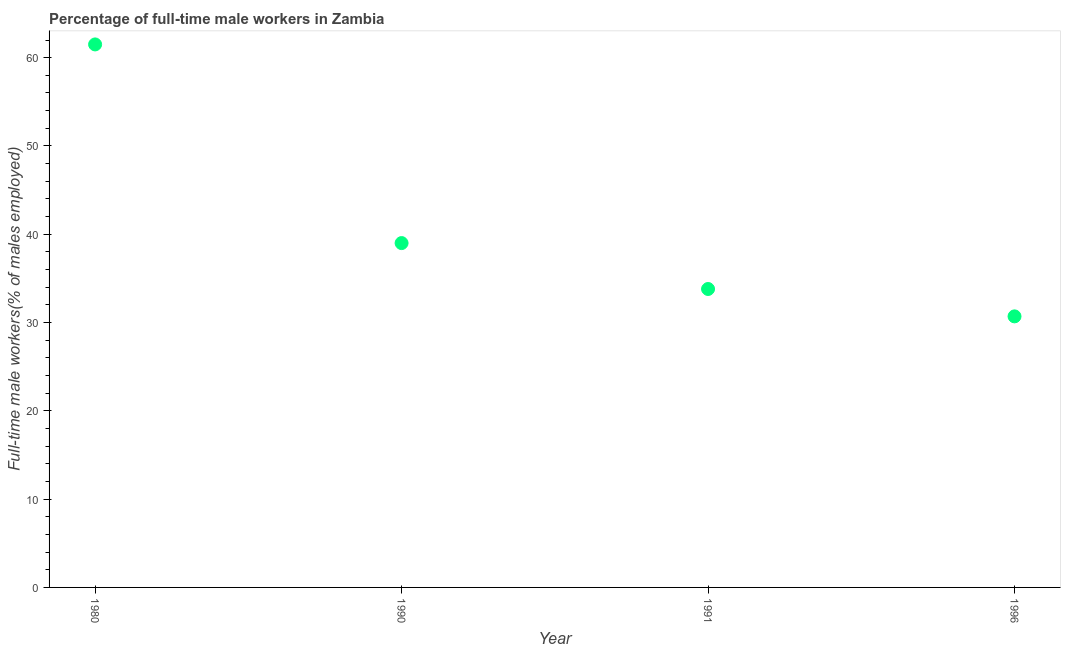What is the percentage of full-time male workers in 1996?
Provide a succinct answer. 30.7. Across all years, what is the maximum percentage of full-time male workers?
Your answer should be very brief. 61.5. Across all years, what is the minimum percentage of full-time male workers?
Ensure brevity in your answer.  30.7. In which year was the percentage of full-time male workers maximum?
Provide a succinct answer. 1980. In which year was the percentage of full-time male workers minimum?
Give a very brief answer. 1996. What is the sum of the percentage of full-time male workers?
Give a very brief answer. 165. What is the difference between the percentage of full-time male workers in 1990 and 1996?
Offer a very short reply. 8.3. What is the average percentage of full-time male workers per year?
Keep it short and to the point. 41.25. What is the median percentage of full-time male workers?
Offer a terse response. 36.4. In how many years, is the percentage of full-time male workers greater than 22 %?
Make the answer very short. 4. What is the ratio of the percentage of full-time male workers in 1990 to that in 1996?
Your response must be concise. 1.27. Is the difference between the percentage of full-time male workers in 1980 and 1991 greater than the difference between any two years?
Provide a succinct answer. No. Is the sum of the percentage of full-time male workers in 1990 and 1991 greater than the maximum percentage of full-time male workers across all years?
Make the answer very short. Yes. What is the difference between the highest and the lowest percentage of full-time male workers?
Offer a very short reply. 30.8. In how many years, is the percentage of full-time male workers greater than the average percentage of full-time male workers taken over all years?
Provide a short and direct response. 1. Does the percentage of full-time male workers monotonically increase over the years?
Provide a short and direct response. No. How many dotlines are there?
Make the answer very short. 1. What is the difference between two consecutive major ticks on the Y-axis?
Your response must be concise. 10. Does the graph contain grids?
Provide a succinct answer. No. What is the title of the graph?
Your answer should be very brief. Percentage of full-time male workers in Zambia. What is the label or title of the X-axis?
Make the answer very short. Year. What is the label or title of the Y-axis?
Provide a succinct answer. Full-time male workers(% of males employed). What is the Full-time male workers(% of males employed) in 1980?
Offer a terse response. 61.5. What is the Full-time male workers(% of males employed) in 1990?
Your answer should be very brief. 39. What is the Full-time male workers(% of males employed) in 1991?
Your answer should be compact. 33.8. What is the Full-time male workers(% of males employed) in 1996?
Your answer should be compact. 30.7. What is the difference between the Full-time male workers(% of males employed) in 1980 and 1990?
Ensure brevity in your answer.  22.5. What is the difference between the Full-time male workers(% of males employed) in 1980 and 1991?
Make the answer very short. 27.7. What is the difference between the Full-time male workers(% of males employed) in 1980 and 1996?
Provide a short and direct response. 30.8. What is the difference between the Full-time male workers(% of males employed) in 1990 and 1991?
Ensure brevity in your answer.  5.2. What is the difference between the Full-time male workers(% of males employed) in 1990 and 1996?
Offer a very short reply. 8.3. What is the difference between the Full-time male workers(% of males employed) in 1991 and 1996?
Offer a very short reply. 3.1. What is the ratio of the Full-time male workers(% of males employed) in 1980 to that in 1990?
Make the answer very short. 1.58. What is the ratio of the Full-time male workers(% of males employed) in 1980 to that in 1991?
Your response must be concise. 1.82. What is the ratio of the Full-time male workers(% of males employed) in 1980 to that in 1996?
Provide a short and direct response. 2. What is the ratio of the Full-time male workers(% of males employed) in 1990 to that in 1991?
Your response must be concise. 1.15. What is the ratio of the Full-time male workers(% of males employed) in 1990 to that in 1996?
Provide a succinct answer. 1.27. What is the ratio of the Full-time male workers(% of males employed) in 1991 to that in 1996?
Keep it short and to the point. 1.1. 